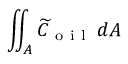<formula> <loc_0><loc_0><loc_500><loc_500>\iint _ { A } \widetilde { C } _ { o i l } \, d A</formula> 